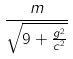<formula> <loc_0><loc_0><loc_500><loc_500>\frac { m } { \sqrt { 9 + \frac { g ^ { 2 } } { c ^ { 2 } } } }</formula> 